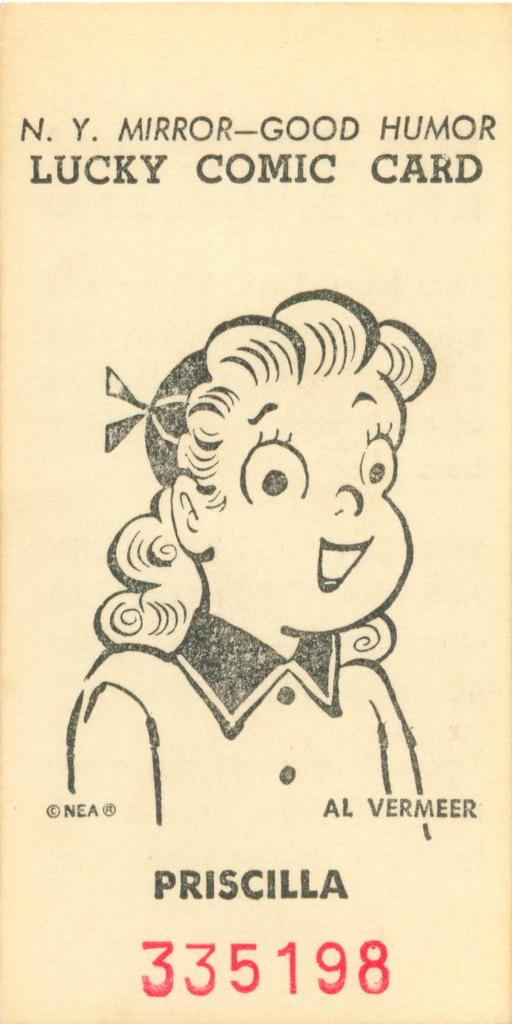What is present in the image that contains information or a message? There is a poster in the image that contains text. Can you describe the content of the poster? The poster contains text and a cartoon girl. How many giraffes can be seen interacting with the cartoon girl on the poster? There are no giraffes depicted on the poster; it features a cartoon girl and text. What type of letter is being delivered by the cartoon girl on the poster? There is no letter or delivery depicted on the poster; it only features a cartoon girl and text. 